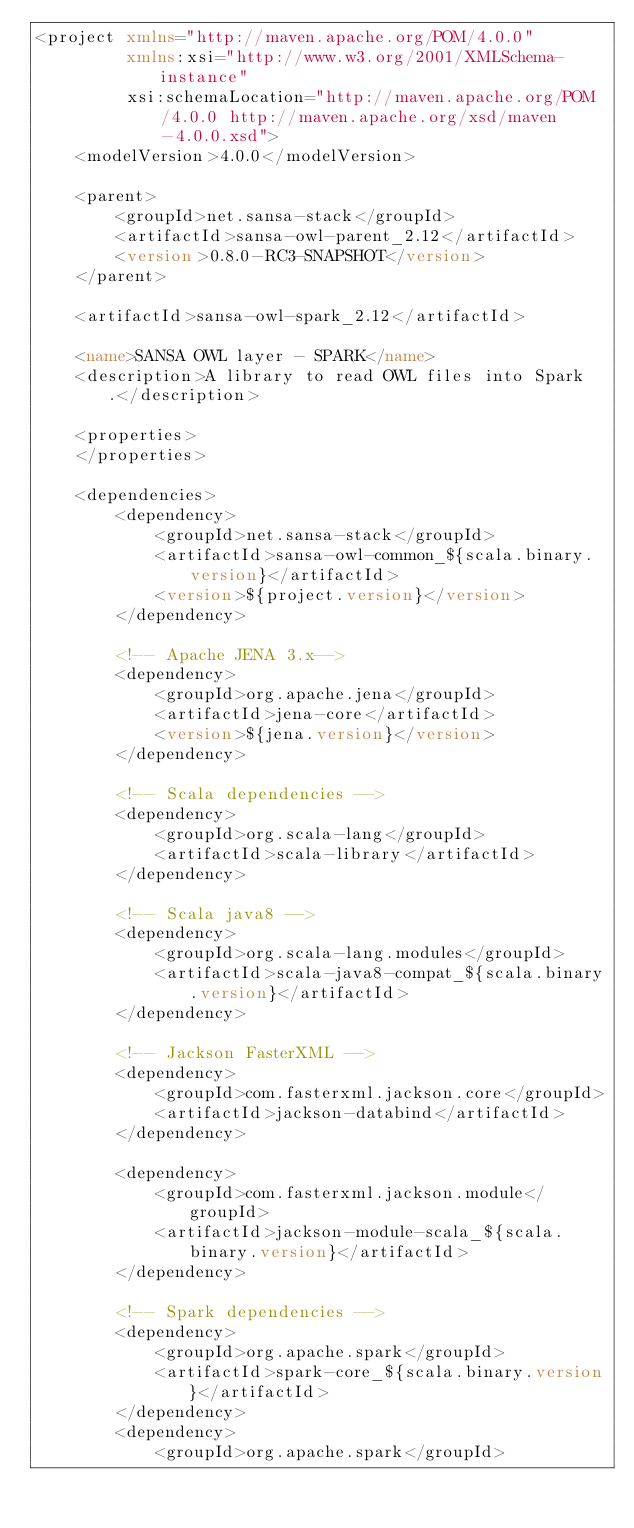<code> <loc_0><loc_0><loc_500><loc_500><_XML_><project xmlns="http://maven.apache.org/POM/4.0.0"
         xmlns:xsi="http://www.w3.org/2001/XMLSchema-instance"
         xsi:schemaLocation="http://maven.apache.org/POM/4.0.0 http://maven.apache.org/xsd/maven-4.0.0.xsd">
    <modelVersion>4.0.0</modelVersion>

    <parent>
        <groupId>net.sansa-stack</groupId>
        <artifactId>sansa-owl-parent_2.12</artifactId>
        <version>0.8.0-RC3-SNAPSHOT</version>
    </parent>

    <artifactId>sansa-owl-spark_2.12</artifactId>

    <name>SANSA OWL layer - SPARK</name>
    <description>A library to read OWL files into Spark.</description>

    <properties>
    </properties>

    <dependencies>
        <dependency>
            <groupId>net.sansa-stack</groupId>
            <artifactId>sansa-owl-common_${scala.binary.version}</artifactId>
            <version>${project.version}</version>
        </dependency>

        <!-- Apache JENA 3.x-->
        <dependency>
            <groupId>org.apache.jena</groupId>
            <artifactId>jena-core</artifactId>
            <version>${jena.version}</version>
        </dependency>

        <!-- Scala dependencies -->
        <dependency>
            <groupId>org.scala-lang</groupId>
            <artifactId>scala-library</artifactId>
        </dependency>

        <!-- Scala java8 -->
        <dependency>
            <groupId>org.scala-lang.modules</groupId>
            <artifactId>scala-java8-compat_${scala.binary.version}</artifactId>
        </dependency>

        <!-- Jackson FasterXML -->
        <dependency>
            <groupId>com.fasterxml.jackson.core</groupId>
            <artifactId>jackson-databind</artifactId>
        </dependency>

        <dependency>
            <groupId>com.fasterxml.jackson.module</groupId>
            <artifactId>jackson-module-scala_${scala.binary.version}</artifactId>
        </dependency>

        <!-- Spark dependencies -->
        <dependency>
            <groupId>org.apache.spark</groupId>
            <artifactId>spark-core_${scala.binary.version}</artifactId>
        </dependency>
        <dependency>
            <groupId>org.apache.spark</groupId></code> 